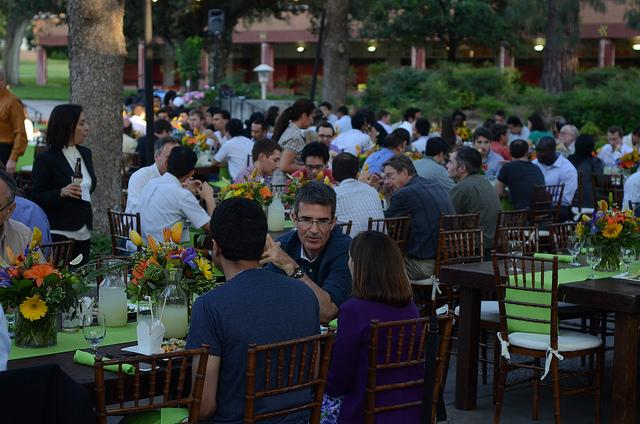What type of event is this?

Choices:
A) show
B) reception
C) presentation
D) meeting reception 